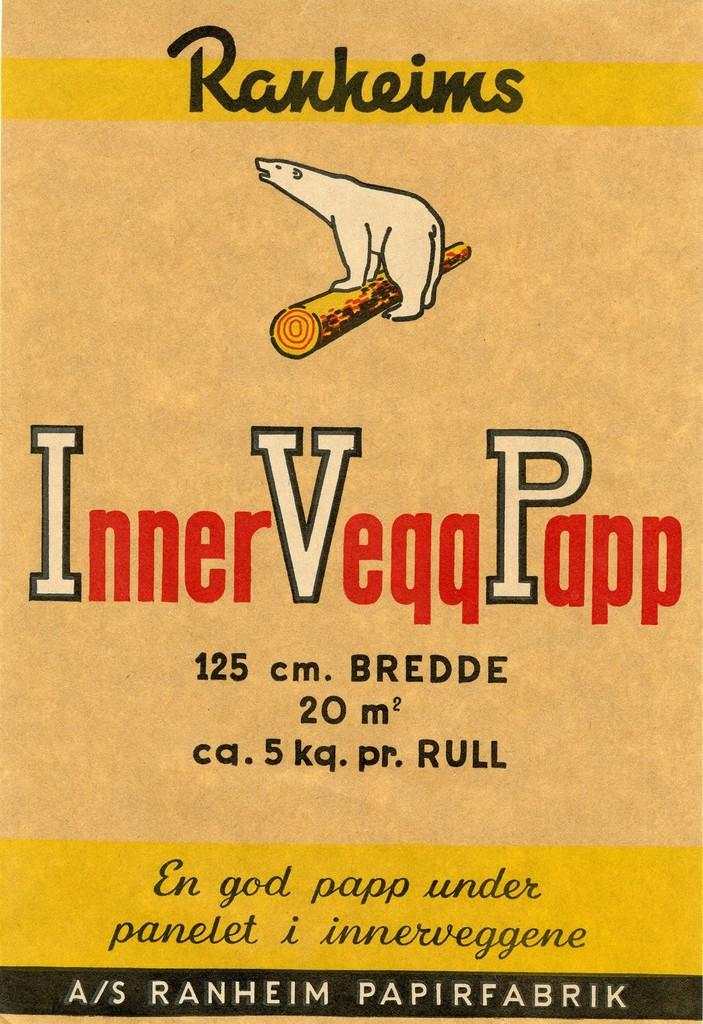Provide a one-sentence caption for the provided image. An advertisement for Inner Veqq Papp features a polar bear on a log. 